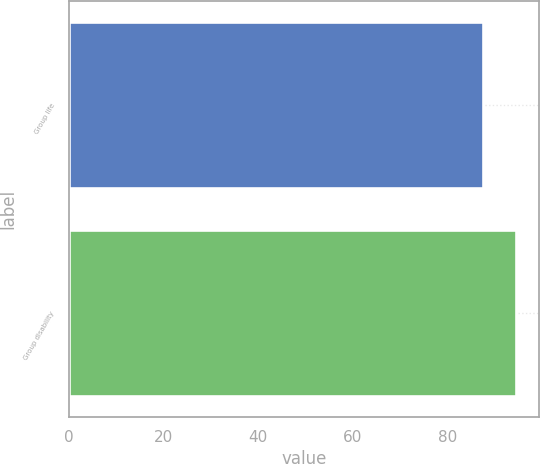Convert chart. <chart><loc_0><loc_0><loc_500><loc_500><bar_chart><fcel>Group life<fcel>Group disability<nl><fcel>87.5<fcel>94.6<nl></chart> 